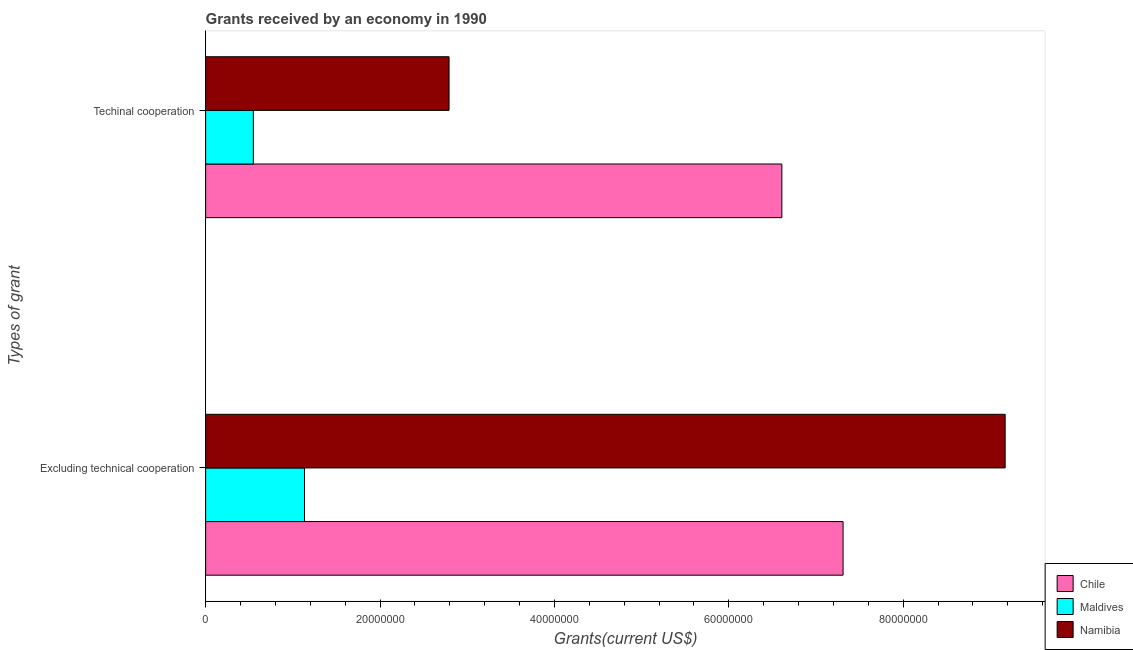How many different coloured bars are there?
Offer a very short reply. 3. How many groups of bars are there?
Keep it short and to the point. 2. Are the number of bars per tick equal to the number of legend labels?
Offer a terse response. Yes. How many bars are there on the 2nd tick from the bottom?
Provide a short and direct response. 3. What is the label of the 2nd group of bars from the top?
Make the answer very short. Excluding technical cooperation. What is the amount of grants received(including technical cooperation) in Chile?
Offer a terse response. 6.61e+07. Across all countries, what is the maximum amount of grants received(including technical cooperation)?
Offer a terse response. 6.61e+07. Across all countries, what is the minimum amount of grants received(excluding technical cooperation)?
Provide a short and direct response. 1.13e+07. In which country was the amount of grants received(including technical cooperation) minimum?
Offer a terse response. Maldives. What is the total amount of grants received(including technical cooperation) in the graph?
Offer a terse response. 9.95e+07. What is the difference between the amount of grants received(excluding technical cooperation) in Namibia and that in Chile?
Your answer should be very brief. 1.86e+07. What is the difference between the amount of grants received(including technical cooperation) in Maldives and the amount of grants received(excluding technical cooperation) in Namibia?
Provide a succinct answer. -8.62e+07. What is the average amount of grants received(including technical cooperation) per country?
Your answer should be very brief. 3.32e+07. What is the difference between the amount of grants received(excluding technical cooperation) and amount of grants received(including technical cooperation) in Chile?
Make the answer very short. 7.02e+06. What is the ratio of the amount of grants received(including technical cooperation) in Maldives to that in Namibia?
Provide a short and direct response. 0.2. Is the amount of grants received(excluding technical cooperation) in Maldives less than that in Namibia?
Offer a very short reply. Yes. In how many countries, is the amount of grants received(excluding technical cooperation) greater than the average amount of grants received(excluding technical cooperation) taken over all countries?
Ensure brevity in your answer.  2. What does the 2nd bar from the top in Excluding technical cooperation represents?
Your answer should be very brief. Maldives. What does the 2nd bar from the bottom in Techinal cooperation represents?
Provide a short and direct response. Maldives. Are all the bars in the graph horizontal?
Your answer should be very brief. Yes. Are the values on the major ticks of X-axis written in scientific E-notation?
Ensure brevity in your answer.  No. Does the graph contain grids?
Provide a succinct answer. No. How are the legend labels stacked?
Offer a very short reply. Vertical. What is the title of the graph?
Ensure brevity in your answer.  Grants received by an economy in 1990. What is the label or title of the X-axis?
Offer a very short reply. Grants(current US$). What is the label or title of the Y-axis?
Provide a succinct answer. Types of grant. What is the Grants(current US$) of Chile in Excluding technical cooperation?
Provide a short and direct response. 7.31e+07. What is the Grants(current US$) of Maldives in Excluding technical cooperation?
Your response must be concise. 1.13e+07. What is the Grants(current US$) in Namibia in Excluding technical cooperation?
Your answer should be compact. 9.17e+07. What is the Grants(current US$) in Chile in Techinal cooperation?
Ensure brevity in your answer.  6.61e+07. What is the Grants(current US$) in Maldives in Techinal cooperation?
Provide a succinct answer. 5.47e+06. What is the Grants(current US$) of Namibia in Techinal cooperation?
Offer a terse response. 2.79e+07. Across all Types of grant, what is the maximum Grants(current US$) of Chile?
Provide a short and direct response. 7.31e+07. Across all Types of grant, what is the maximum Grants(current US$) of Maldives?
Keep it short and to the point. 1.13e+07. Across all Types of grant, what is the maximum Grants(current US$) of Namibia?
Offer a very short reply. 9.17e+07. Across all Types of grant, what is the minimum Grants(current US$) in Chile?
Offer a very short reply. 6.61e+07. Across all Types of grant, what is the minimum Grants(current US$) of Maldives?
Give a very brief answer. 5.47e+06. Across all Types of grant, what is the minimum Grants(current US$) in Namibia?
Provide a short and direct response. 2.79e+07. What is the total Grants(current US$) of Chile in the graph?
Offer a very short reply. 1.39e+08. What is the total Grants(current US$) in Maldives in the graph?
Give a very brief answer. 1.68e+07. What is the total Grants(current US$) in Namibia in the graph?
Your response must be concise. 1.20e+08. What is the difference between the Grants(current US$) of Chile in Excluding technical cooperation and that in Techinal cooperation?
Give a very brief answer. 7.02e+06. What is the difference between the Grants(current US$) in Maldives in Excluding technical cooperation and that in Techinal cooperation?
Your answer should be very brief. 5.87e+06. What is the difference between the Grants(current US$) of Namibia in Excluding technical cooperation and that in Techinal cooperation?
Ensure brevity in your answer.  6.38e+07. What is the difference between the Grants(current US$) in Chile in Excluding technical cooperation and the Grants(current US$) in Maldives in Techinal cooperation?
Give a very brief answer. 6.76e+07. What is the difference between the Grants(current US$) in Chile in Excluding technical cooperation and the Grants(current US$) in Namibia in Techinal cooperation?
Keep it short and to the point. 4.52e+07. What is the difference between the Grants(current US$) in Maldives in Excluding technical cooperation and the Grants(current US$) in Namibia in Techinal cooperation?
Provide a short and direct response. -1.66e+07. What is the average Grants(current US$) of Chile per Types of grant?
Offer a terse response. 6.96e+07. What is the average Grants(current US$) of Maldives per Types of grant?
Offer a terse response. 8.40e+06. What is the average Grants(current US$) of Namibia per Types of grant?
Ensure brevity in your answer.  5.98e+07. What is the difference between the Grants(current US$) in Chile and Grants(current US$) in Maldives in Excluding technical cooperation?
Offer a very short reply. 6.18e+07. What is the difference between the Grants(current US$) in Chile and Grants(current US$) in Namibia in Excluding technical cooperation?
Offer a terse response. -1.86e+07. What is the difference between the Grants(current US$) of Maldives and Grants(current US$) of Namibia in Excluding technical cooperation?
Ensure brevity in your answer.  -8.04e+07. What is the difference between the Grants(current US$) in Chile and Grants(current US$) in Maldives in Techinal cooperation?
Your answer should be compact. 6.06e+07. What is the difference between the Grants(current US$) of Chile and Grants(current US$) of Namibia in Techinal cooperation?
Provide a succinct answer. 3.82e+07. What is the difference between the Grants(current US$) in Maldives and Grants(current US$) in Namibia in Techinal cooperation?
Your answer should be very brief. -2.24e+07. What is the ratio of the Grants(current US$) in Chile in Excluding technical cooperation to that in Techinal cooperation?
Give a very brief answer. 1.11. What is the ratio of the Grants(current US$) in Maldives in Excluding technical cooperation to that in Techinal cooperation?
Ensure brevity in your answer.  2.07. What is the ratio of the Grants(current US$) in Namibia in Excluding technical cooperation to that in Techinal cooperation?
Ensure brevity in your answer.  3.28. What is the difference between the highest and the second highest Grants(current US$) of Chile?
Provide a short and direct response. 7.02e+06. What is the difference between the highest and the second highest Grants(current US$) of Maldives?
Provide a short and direct response. 5.87e+06. What is the difference between the highest and the second highest Grants(current US$) of Namibia?
Make the answer very short. 6.38e+07. What is the difference between the highest and the lowest Grants(current US$) of Chile?
Provide a short and direct response. 7.02e+06. What is the difference between the highest and the lowest Grants(current US$) of Maldives?
Keep it short and to the point. 5.87e+06. What is the difference between the highest and the lowest Grants(current US$) in Namibia?
Your answer should be very brief. 6.38e+07. 